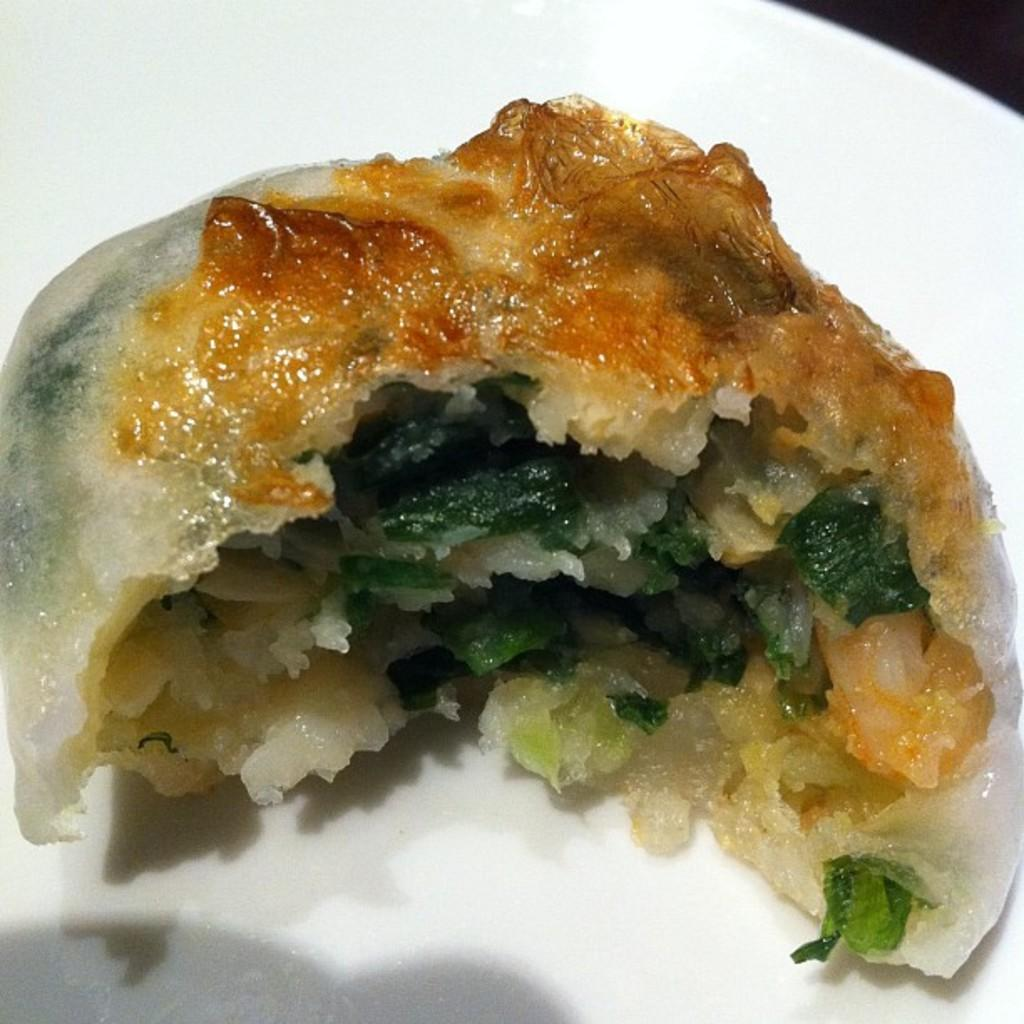What is on the plate in the image? There is food on a plate in the image. What type of garnish is used in the food? The food has mint leaves in it. Can you see a hole in the plate in the image? There is no hole visible in the plate in the image. 